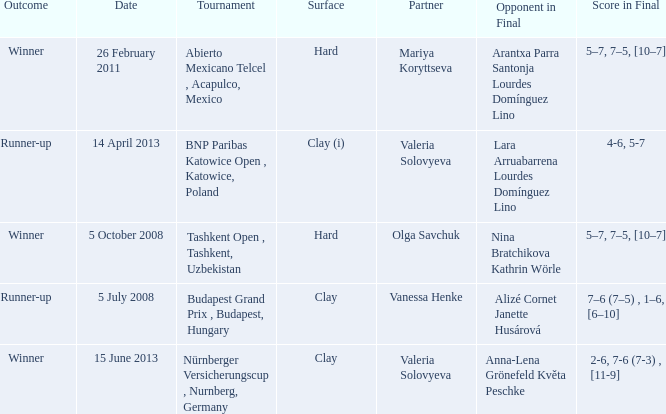Name the outcome for alizé cornet janette husárová being opponent in final Runner-up. 